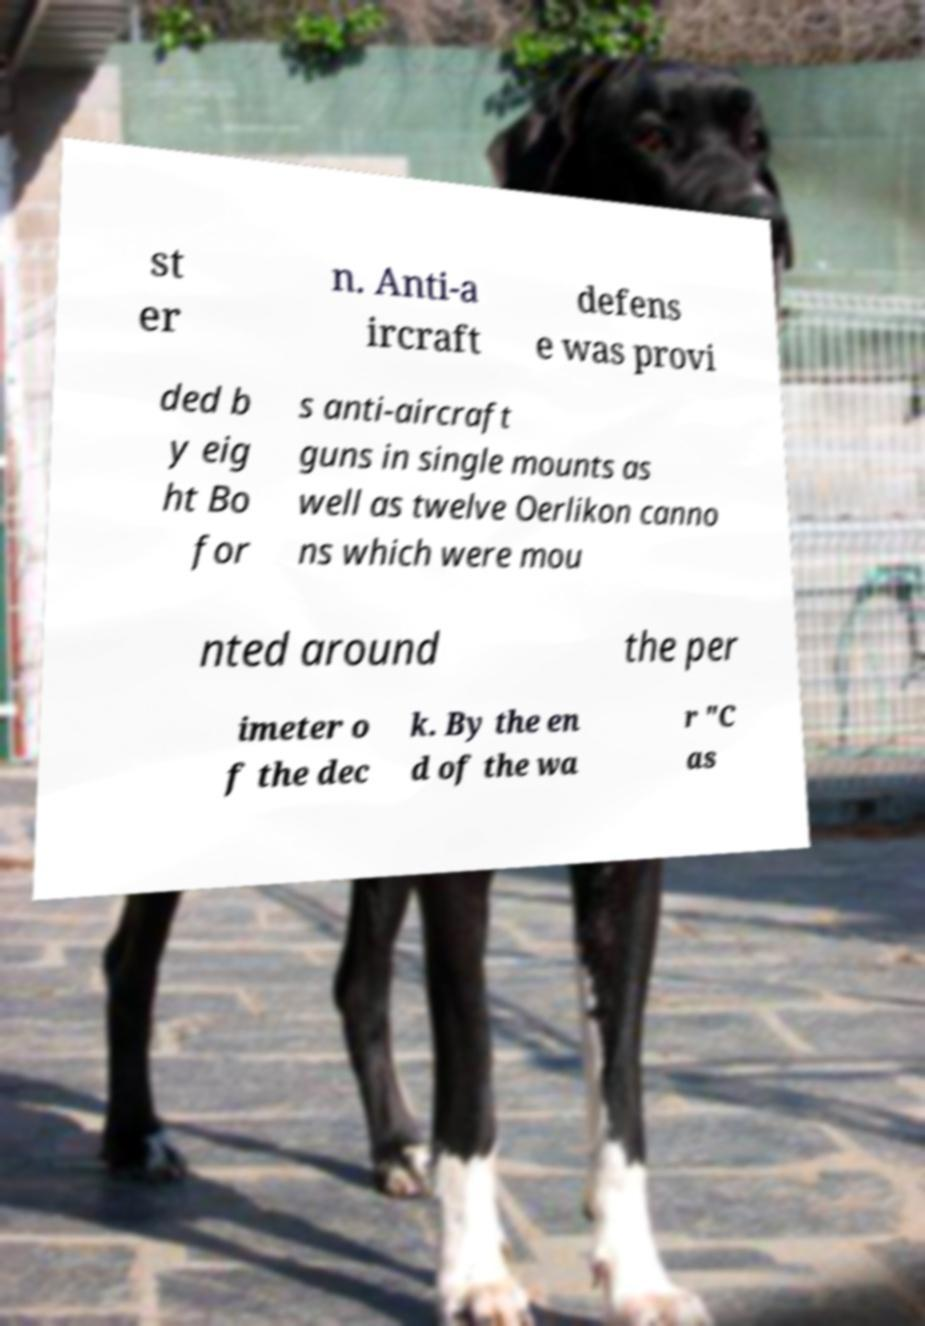Could you assist in decoding the text presented in this image and type it out clearly? st er n. Anti-a ircraft defens e was provi ded b y eig ht Bo for s anti-aircraft guns in single mounts as well as twelve Oerlikon canno ns which were mou nted around the per imeter o f the dec k. By the en d of the wa r "C as 